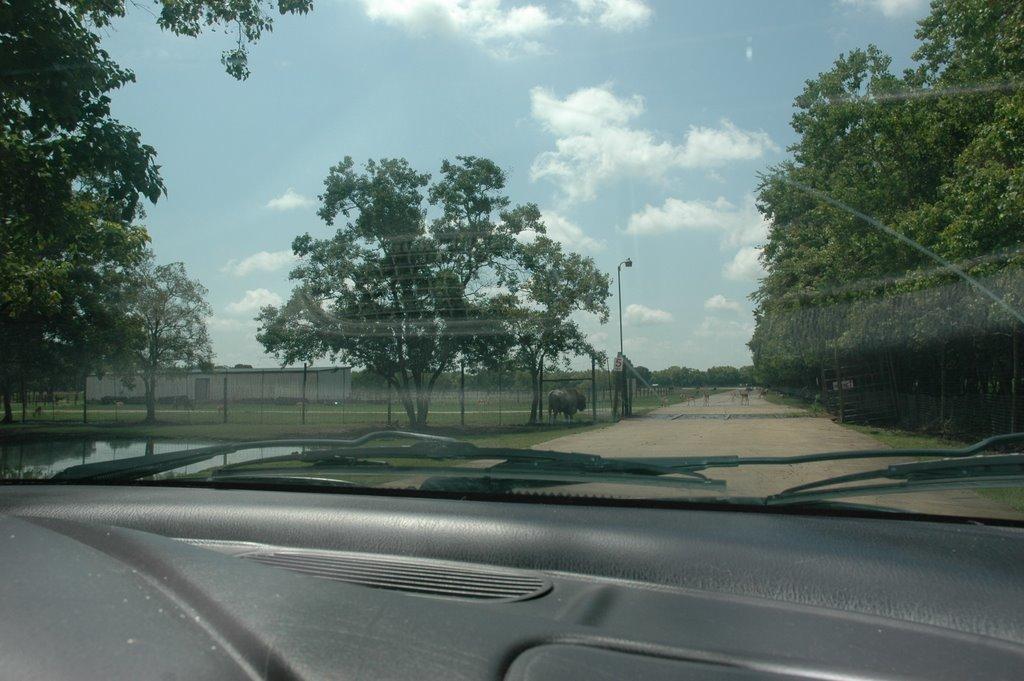Can you describe this image briefly? In this image we can see car mirror, dash board, wiper and in the background of the image there are some trees, walkway, animals, fencing and sunny sky. 